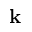Convert formula to latex. <formula><loc_0><loc_0><loc_500><loc_500>{ k }</formula> 